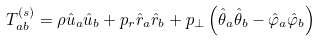<formula> <loc_0><loc_0><loc_500><loc_500>T _ { a b } ^ { ( s ) } = \rho \hat { u } _ { a } \hat { u } _ { b } + p _ { r } \hat { r } _ { a } \hat { r } _ { b } + p _ { \bot } \left ( \hat { \theta } _ { a } \hat { \theta } _ { b } - \hat { \varphi } _ { a } \hat { \varphi } _ { b } \right )</formula> 